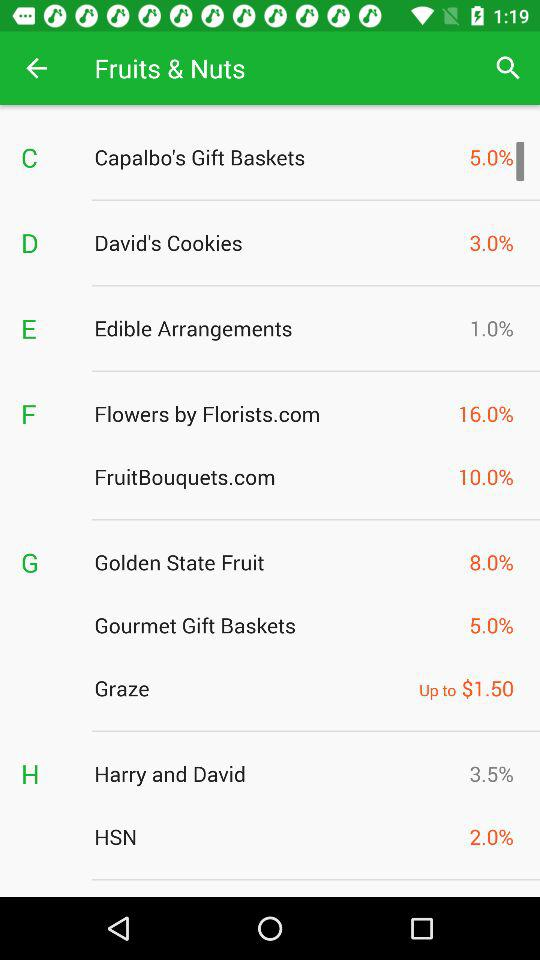What is the percentage of "Edible Arrangements"? The percentage of "Edible Arrangements" is 1. 